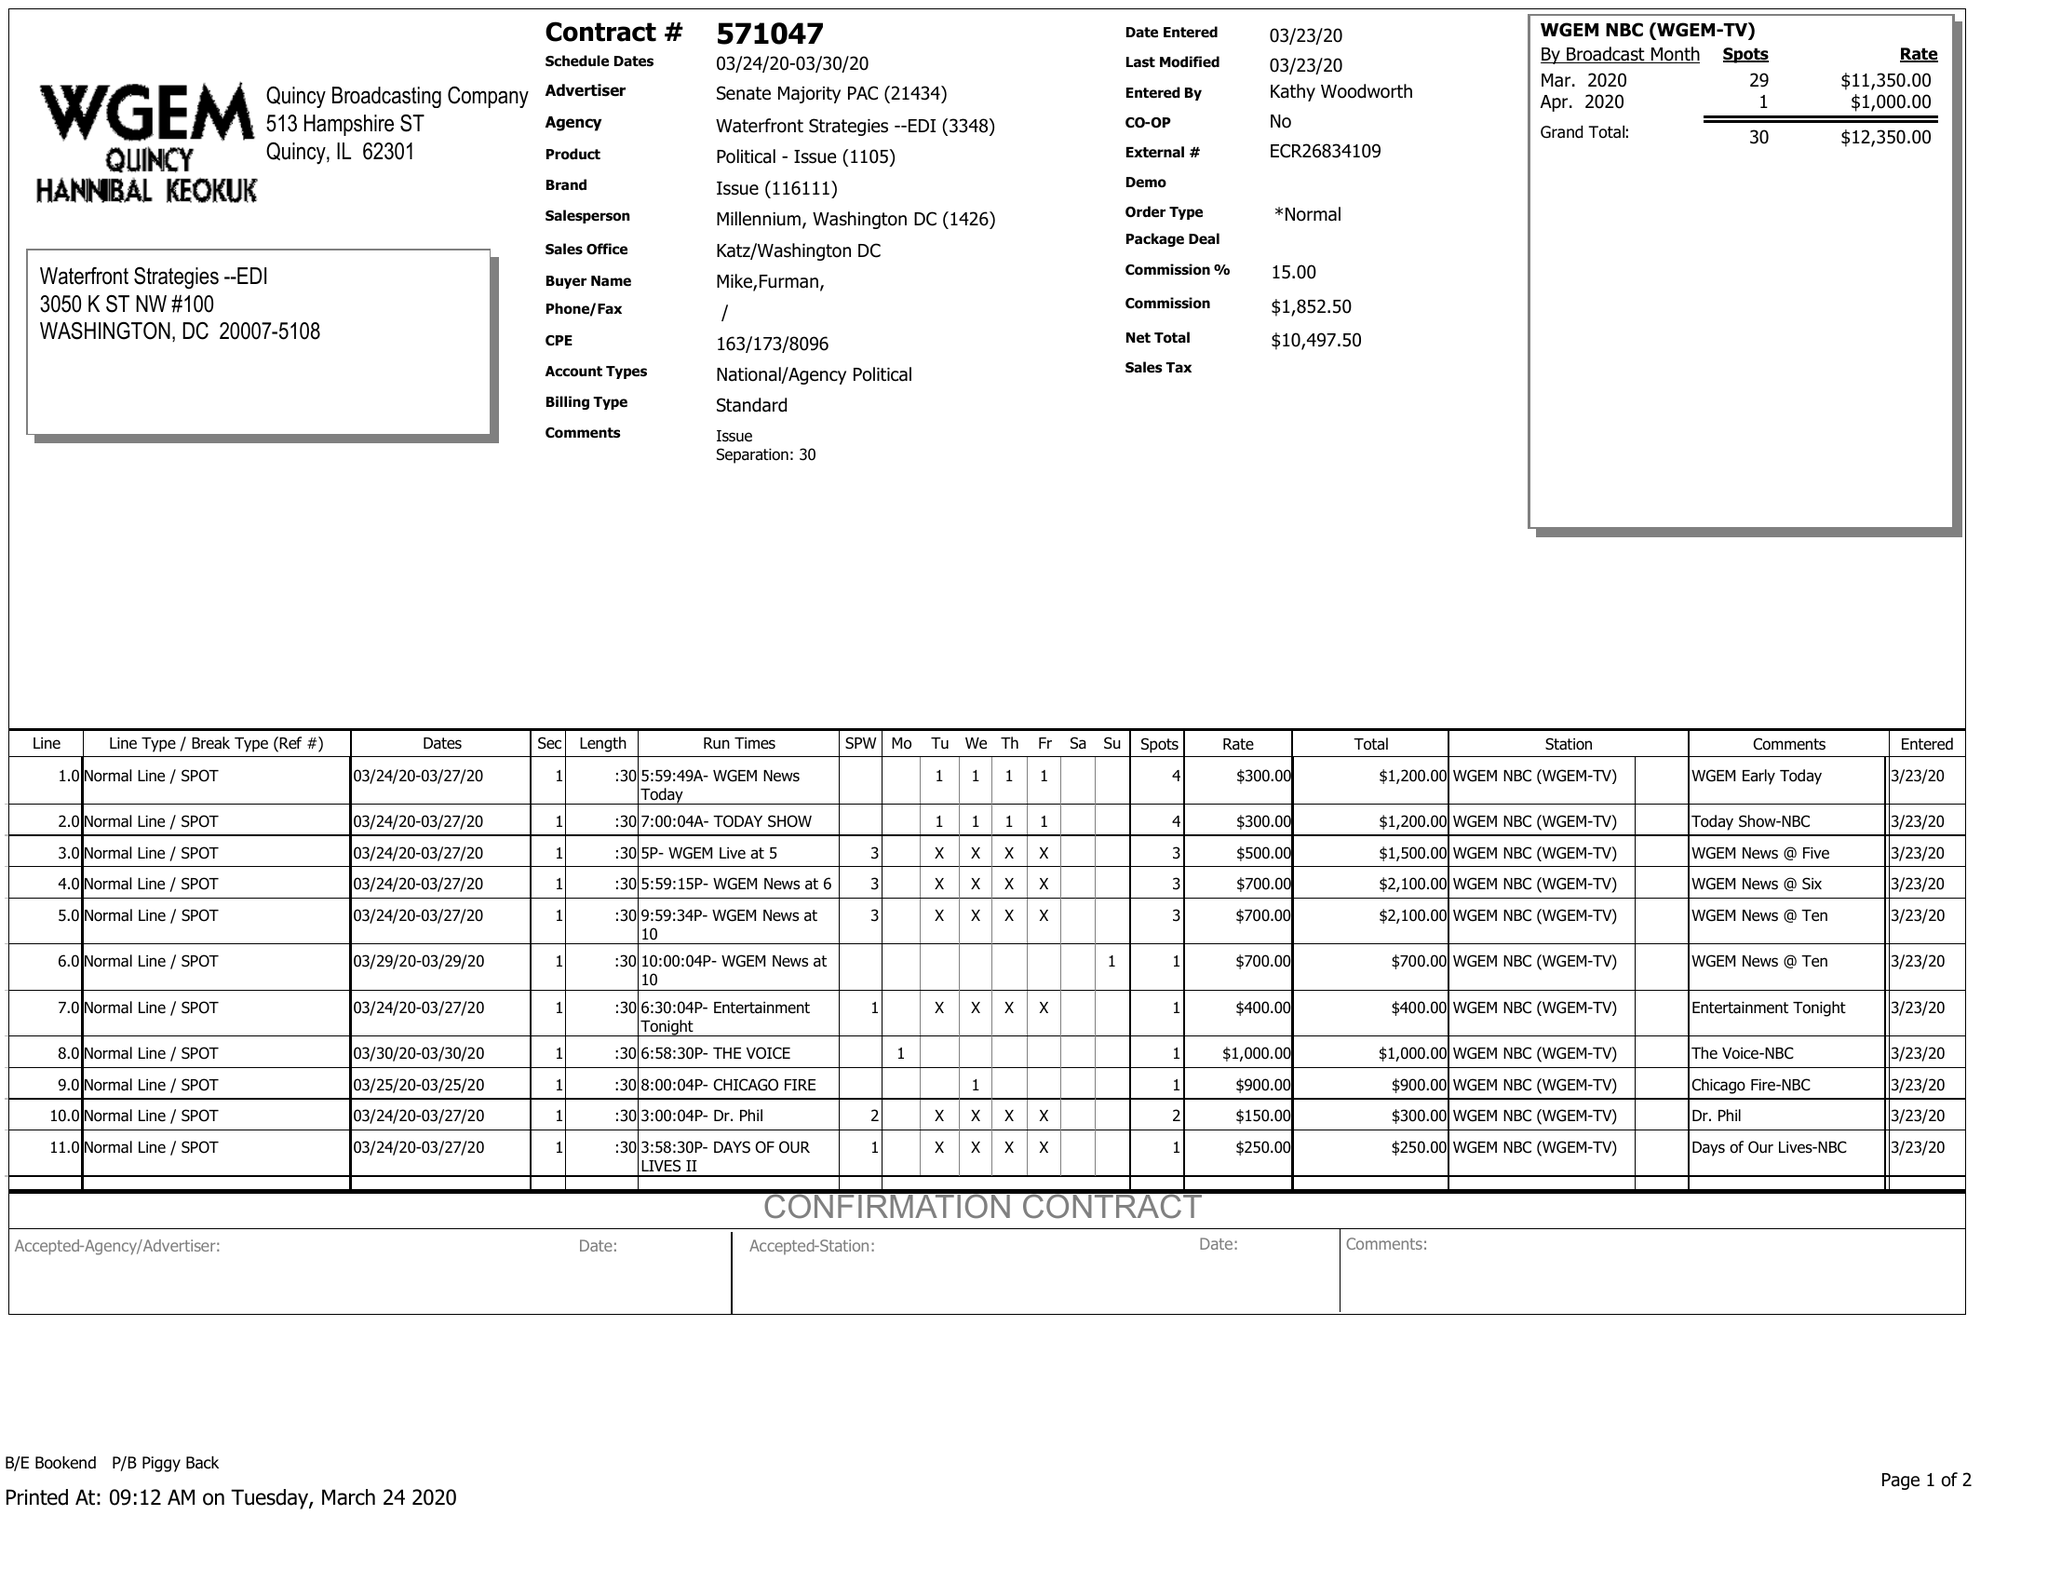What is the value for the gross_amount?
Answer the question using a single word or phrase. 12350.00 